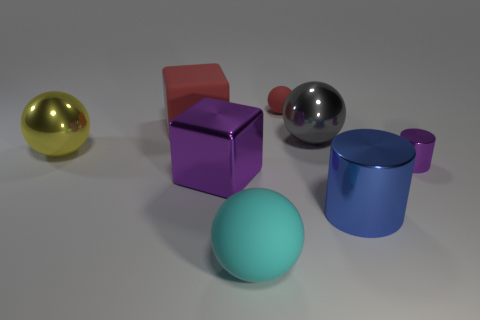There is a yellow thing that is the same size as the purple shiny cube; what is its material?
Make the answer very short. Metal. Do the gray thing and the sphere to the left of the big red matte object have the same size?
Offer a terse response. Yes. What is the material of the big ball in front of the big blue shiny cylinder?
Your answer should be very brief. Rubber. Are there an equal number of big matte things on the left side of the large purple object and purple metal cubes?
Keep it short and to the point. Yes. Does the yellow ball have the same size as the gray shiny thing?
Your response must be concise. Yes. There is a matte sphere that is behind the big rubber object that is to the left of the large cyan rubber object; are there any big metal things that are to the left of it?
Offer a very short reply. Yes. What material is the big gray object that is the same shape as the cyan object?
Your response must be concise. Metal. There is a sphere that is on the left side of the large red object; how many balls are to the right of it?
Keep it short and to the point. 3. What size is the rubber object on the left side of the purple object that is in front of the small thing on the right side of the small red ball?
Your answer should be compact. Large. What is the color of the matte sphere in front of the shiny cylinder that is to the right of the blue metal cylinder?
Your answer should be compact. Cyan. 